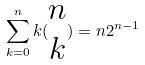Convert formula to latex. <formula><loc_0><loc_0><loc_500><loc_500>\sum _ { k = 0 } ^ { n } k ( \begin{matrix} n \\ k \end{matrix} ) = n 2 ^ { n - 1 }</formula> 